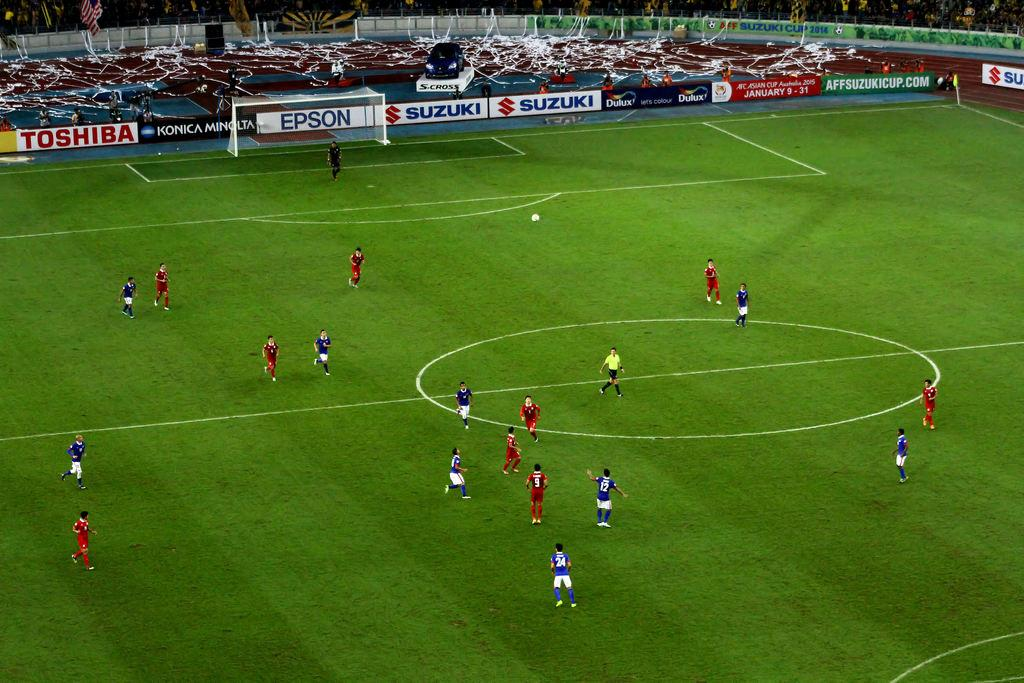<image>
Share a concise interpretation of the image provided. Teams are playing soccer on a field with an advertisement for Suzuki behind them. 